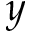Convert formula to latex. <formula><loc_0><loc_0><loc_500><loc_500>y</formula> 